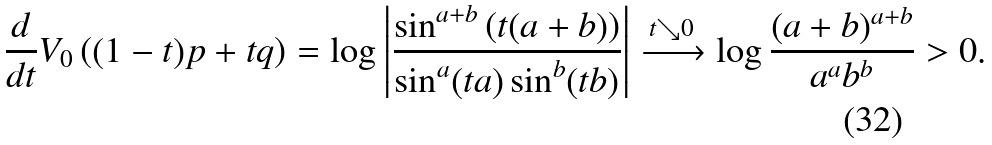<formula> <loc_0><loc_0><loc_500><loc_500>\frac { d } { d t } V _ { 0 } \left ( ( 1 - t ) p + t q \right ) = \log \left | \frac { \sin ^ { a + b } \left ( t ( a + b ) \right ) } { \sin ^ { a } ( t a ) \sin ^ { b } ( t b ) } \right | \xrightarrow { t \searrow 0 } \log \frac { ( a + b ) ^ { a + b } } { a ^ { a } b ^ { b } } > 0 .</formula> 